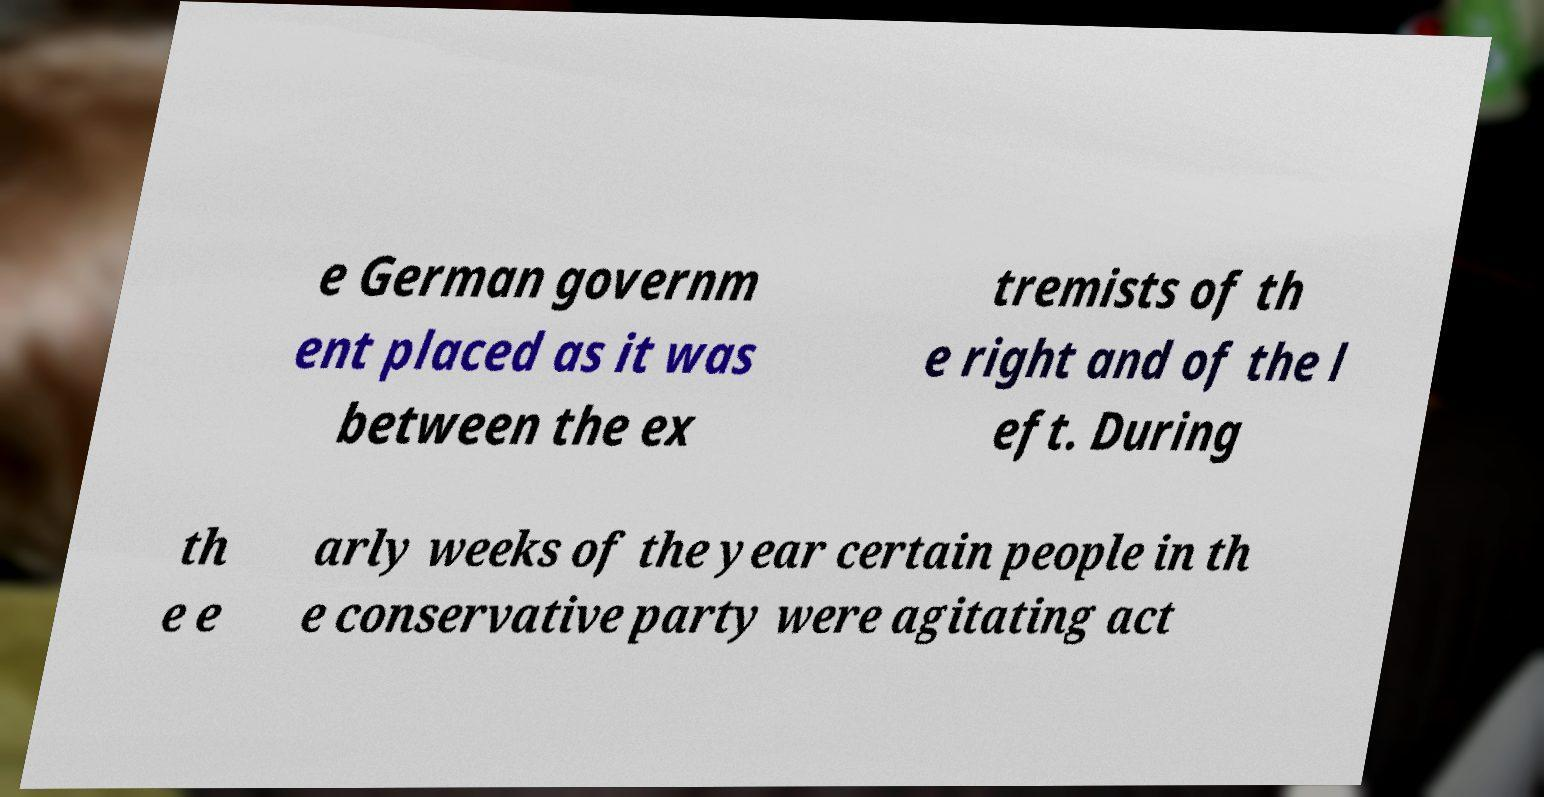Can you accurately transcribe the text from the provided image for me? e German governm ent placed as it was between the ex tremists of th e right and of the l eft. During th e e arly weeks of the year certain people in th e conservative party were agitating act 